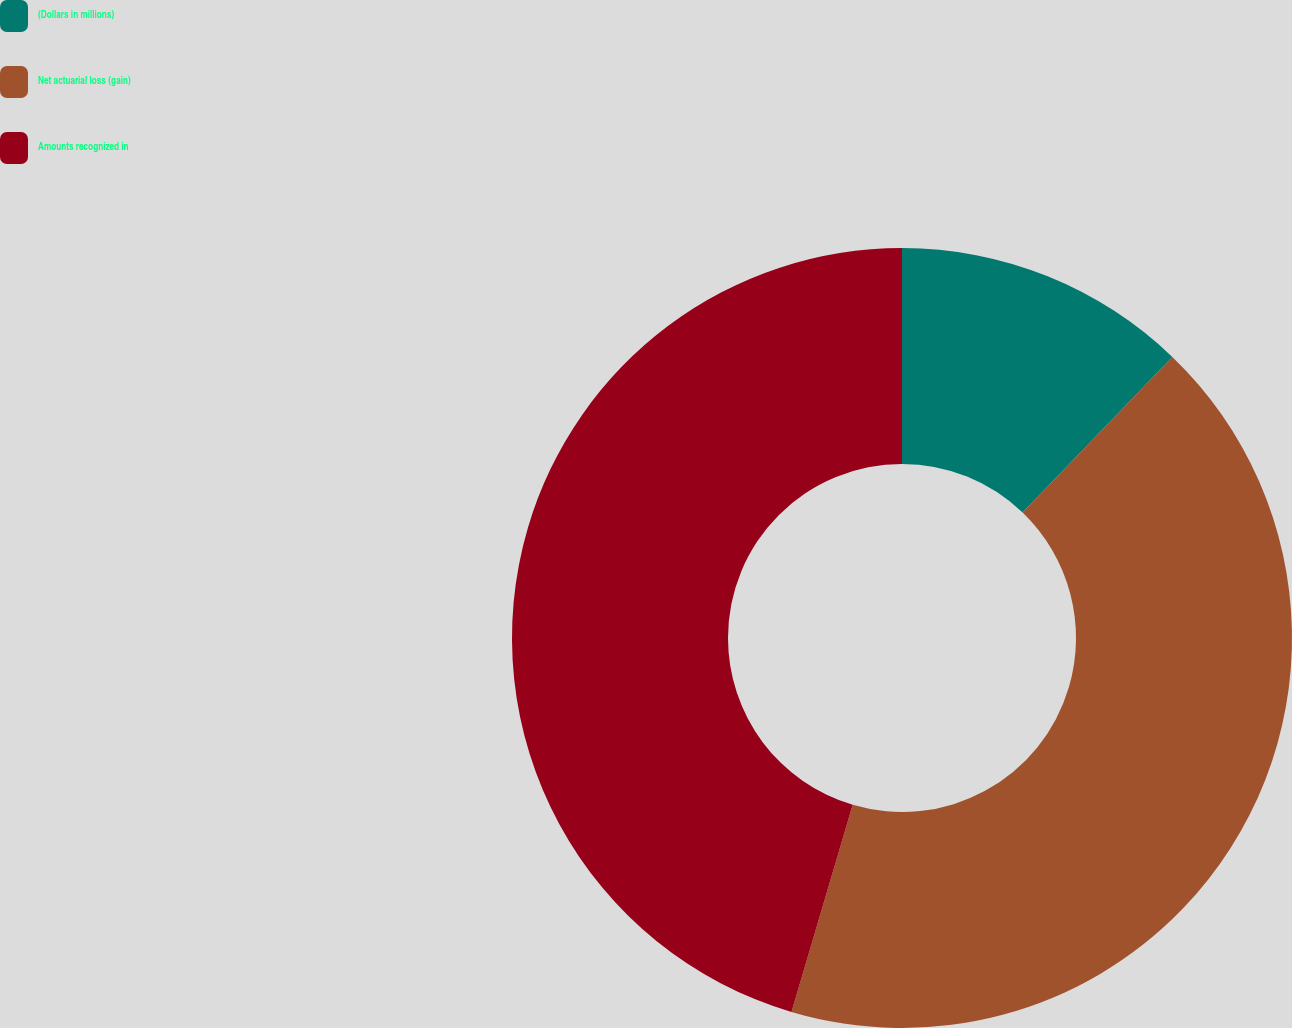<chart> <loc_0><loc_0><loc_500><loc_500><pie_chart><fcel>(Dollars in millions)<fcel>Net actuarial loss (gain)<fcel>Amounts recognized in<nl><fcel>12.19%<fcel>42.39%<fcel>45.43%<nl></chart> 